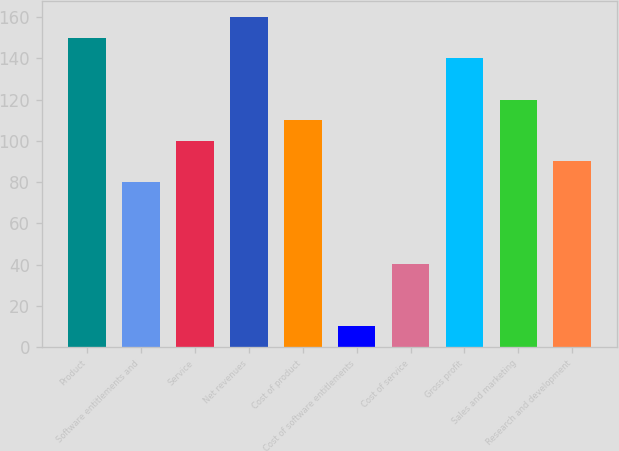Convert chart to OTSL. <chart><loc_0><loc_0><loc_500><loc_500><bar_chart><fcel>Product<fcel>Software entitlements and<fcel>Service<fcel>Net revenues<fcel>Cost of product<fcel>Cost of software entitlements<fcel>Cost of service<fcel>Gross profit<fcel>Sales and marketing<fcel>Research and development<nl><fcel>149.95<fcel>80.02<fcel>100<fcel>159.94<fcel>109.99<fcel>10.09<fcel>40.06<fcel>139.96<fcel>119.98<fcel>90.01<nl></chart> 